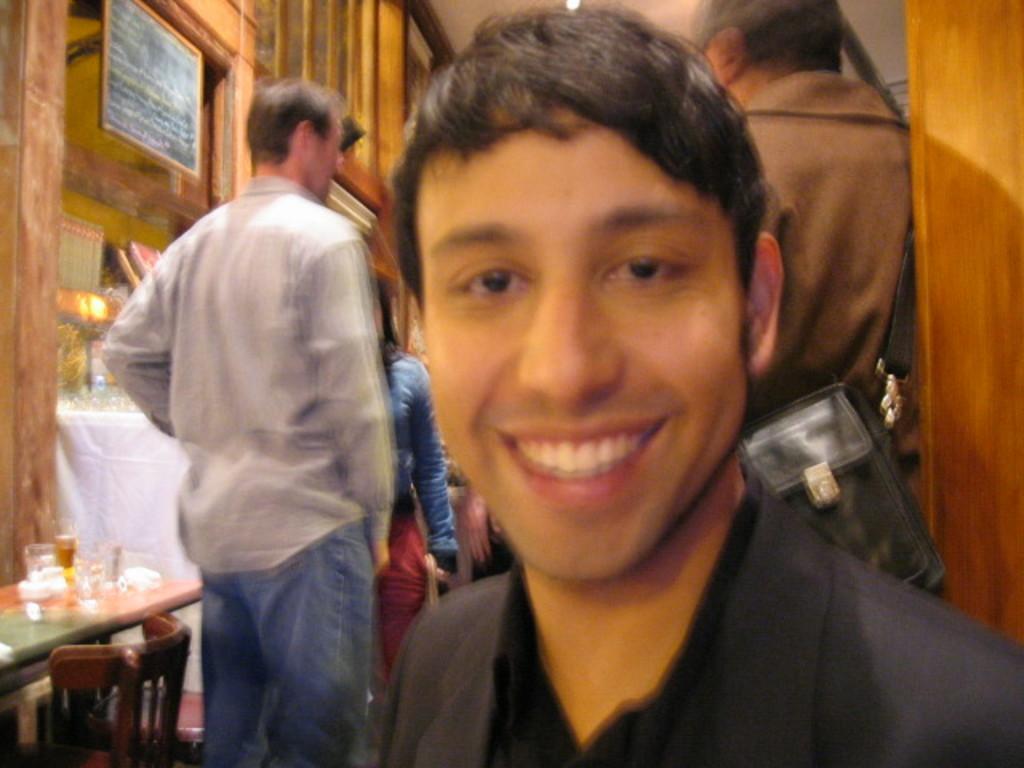Describe this image in one or two sentences. On the background we can see cupboards and a board. Here we can see persons standing. We can see one man in front of the picture and he is smiling. At the left side of the picture we can see a chair and a table. On the table we can see glasses, tissue paper. 